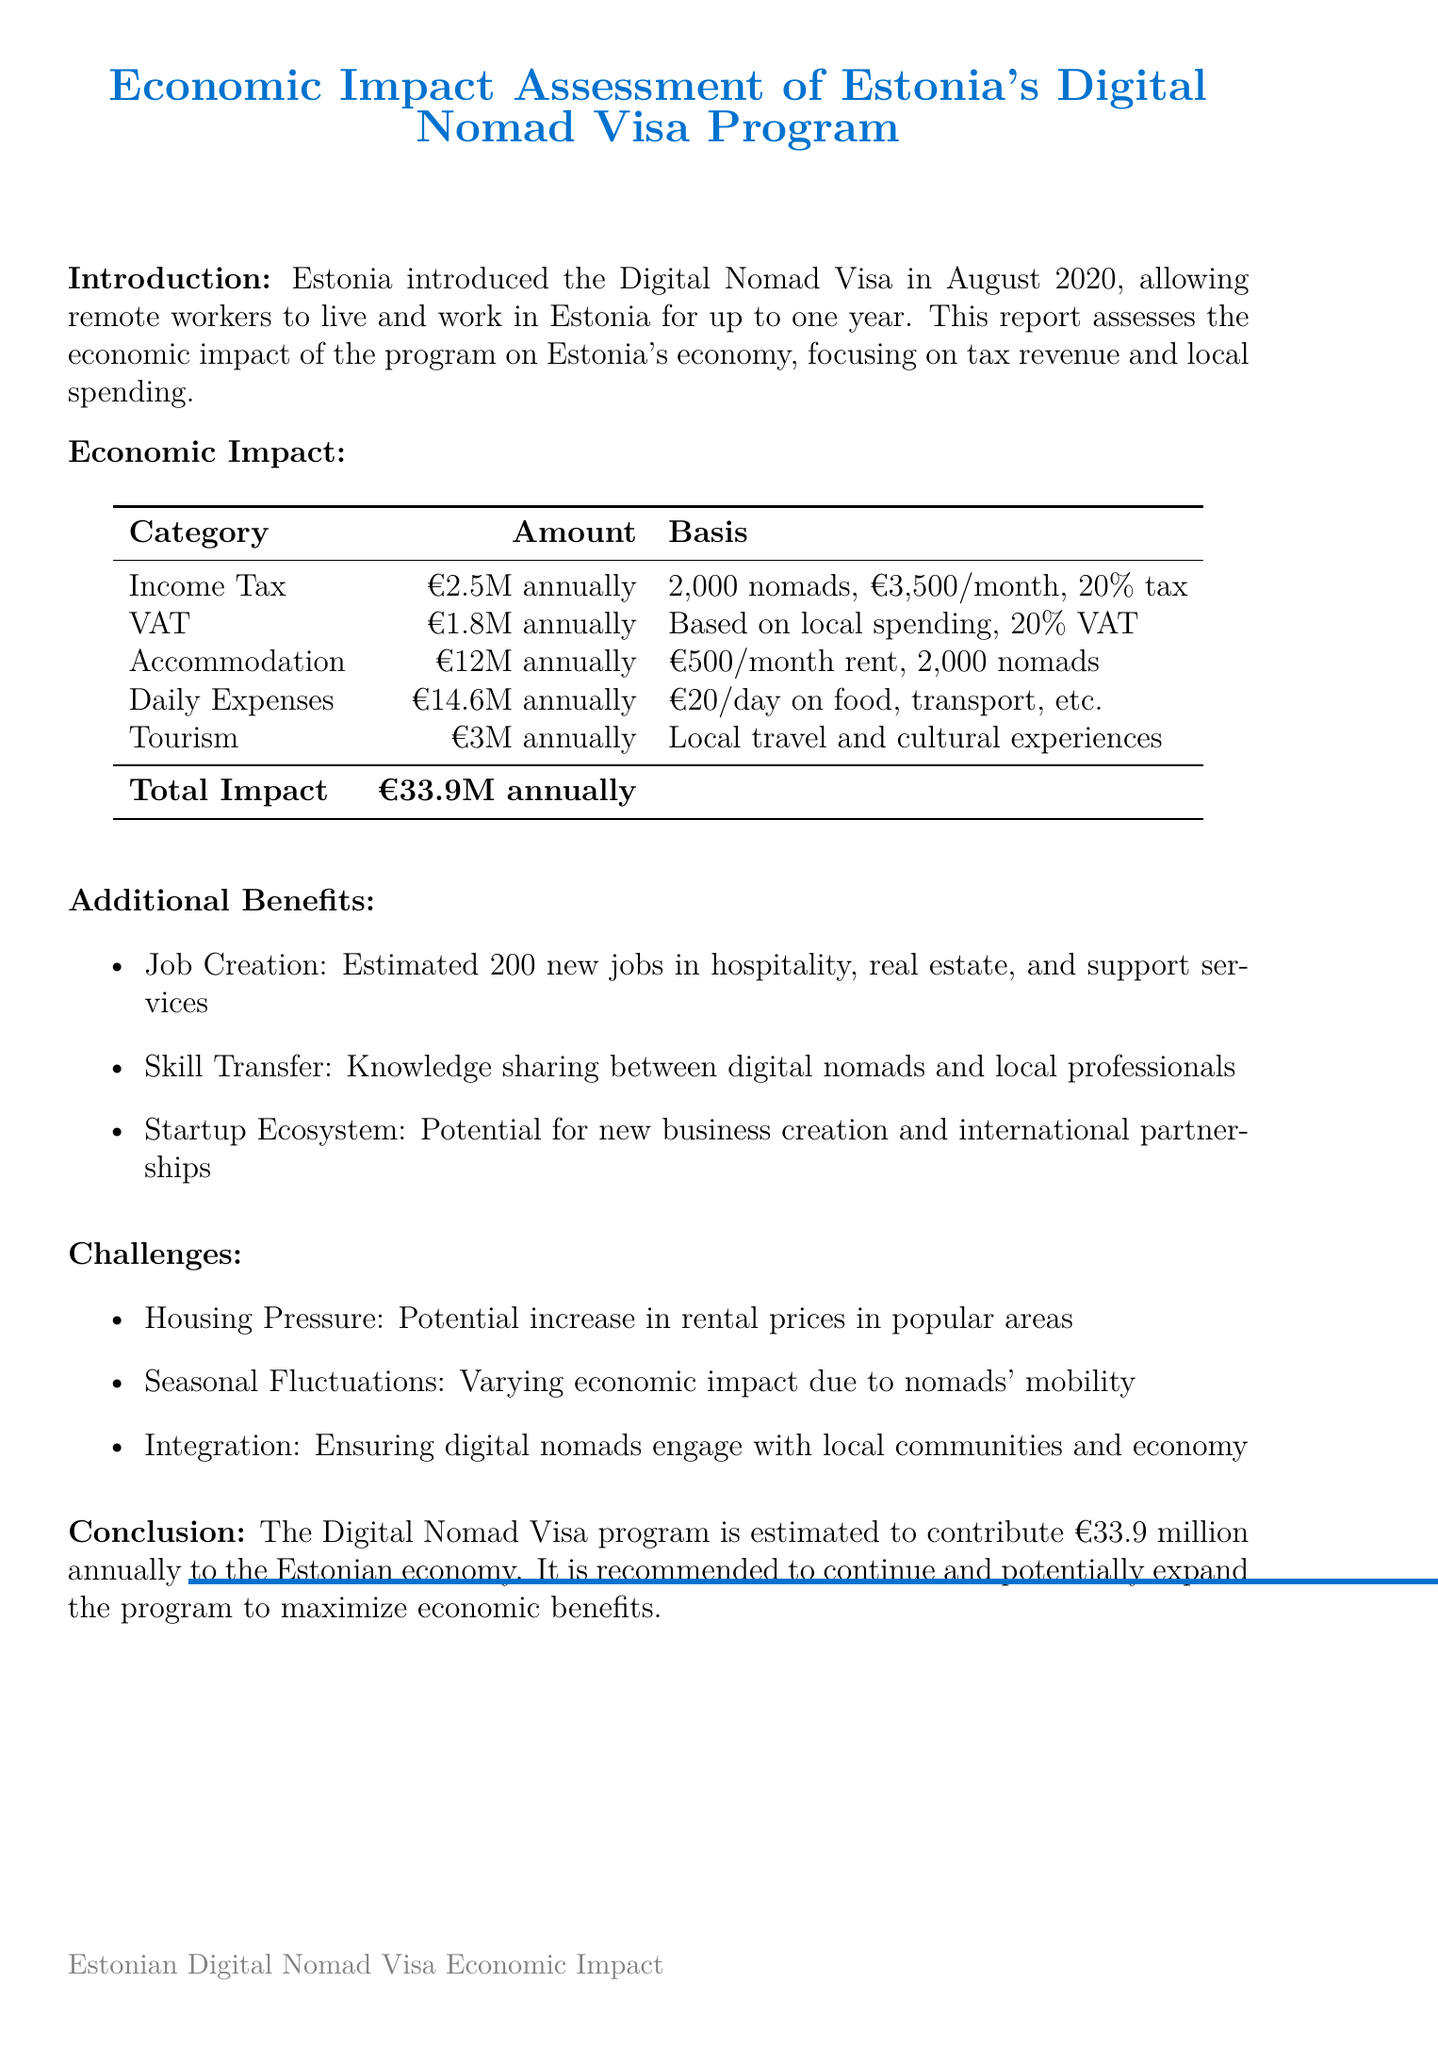What is the total economic impact of the program? The total economic impact is the sum of all contributions listed under local spending and tax revenue, which results in €33.9 million annually.
Answer: €33.9 million What is the estimated annual income tax revenue? The estimated annual income tax revenue is provided in the tax revenue section, based on the number of nomads and their average income.
Answer: €2.5 million annually How many new jobs are estimated to be created? The document mentions the estimated number of new jobs created as a result of the program, specifically in certain sectors.
Answer: 200 What is the average monthly rent for digital nomads? The average monthly rent for digital nomads is calculated based on their accommodation spending estimates.
Answer: €500 What are the tourism-related spending estimates? This is the total spending on local travel and cultural experiences reported in the local spending section.
Answer: €3 million annually What challenges are associated with the Digital Nomad Visa program? Various challenges are listed, indicating potential issues arising from the program's implementation.
Answer: Housing pressure, seasonal fluctuations, integration What is the basis for the estimated VAT revenue? The VAT revenue estimate is based on the estimation of local spending and the VAT rate applied in Estonia.
Answer: Based on estimated local spending and Estonia's 20% VAT rate 